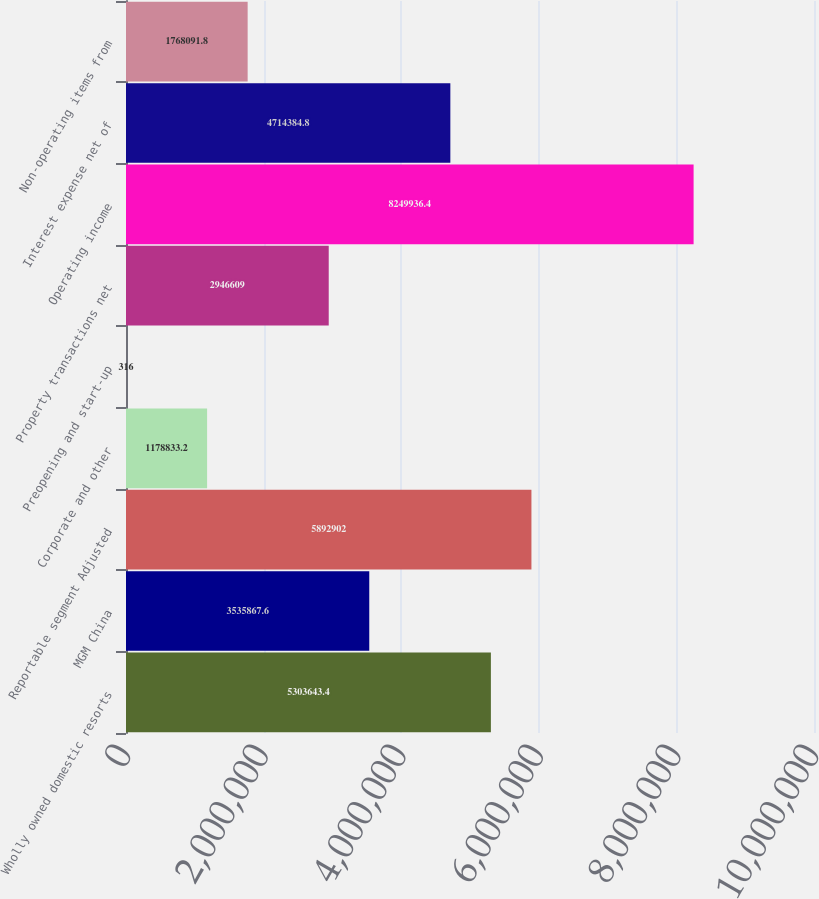Convert chart to OTSL. <chart><loc_0><loc_0><loc_500><loc_500><bar_chart><fcel>Wholly owned domestic resorts<fcel>MGM China<fcel>Reportable segment Adjusted<fcel>Corporate and other<fcel>Preopening and start-up<fcel>Property transactions net<fcel>Operating income<fcel>Interest expense net of<fcel>Non-operating items from<nl><fcel>5.30364e+06<fcel>3.53587e+06<fcel>5.8929e+06<fcel>1.17883e+06<fcel>316<fcel>2.94661e+06<fcel>8.24994e+06<fcel>4.71438e+06<fcel>1.76809e+06<nl></chart> 